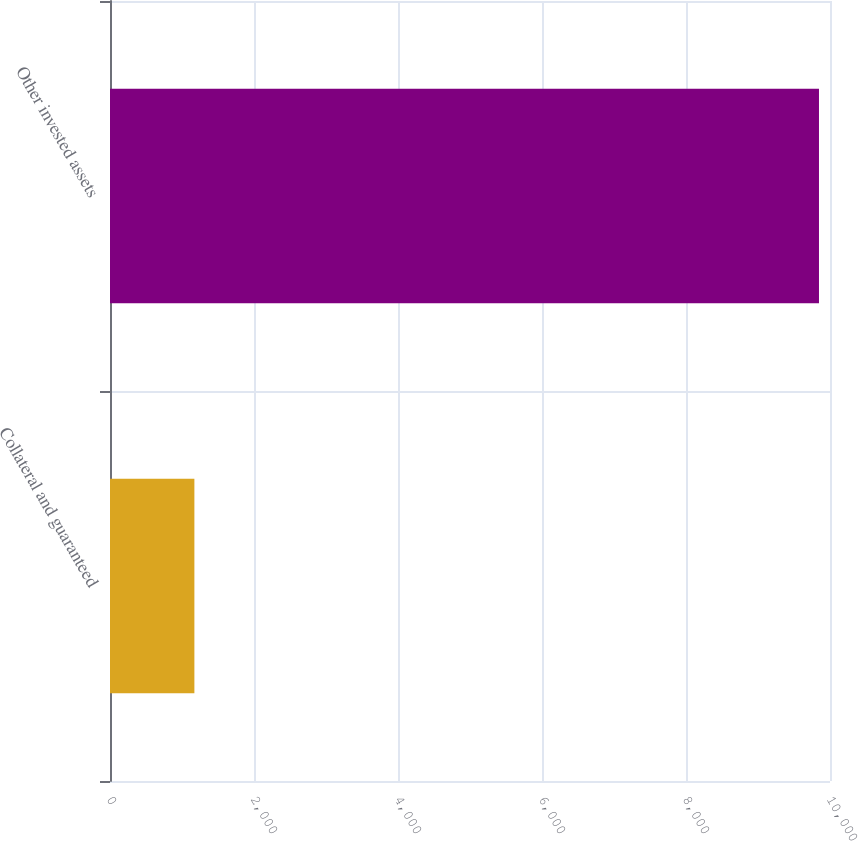<chart> <loc_0><loc_0><loc_500><loc_500><bar_chart><fcel>Collateral and guaranteed<fcel>Other invested assets<nl><fcel>1172<fcel>9847<nl></chart> 